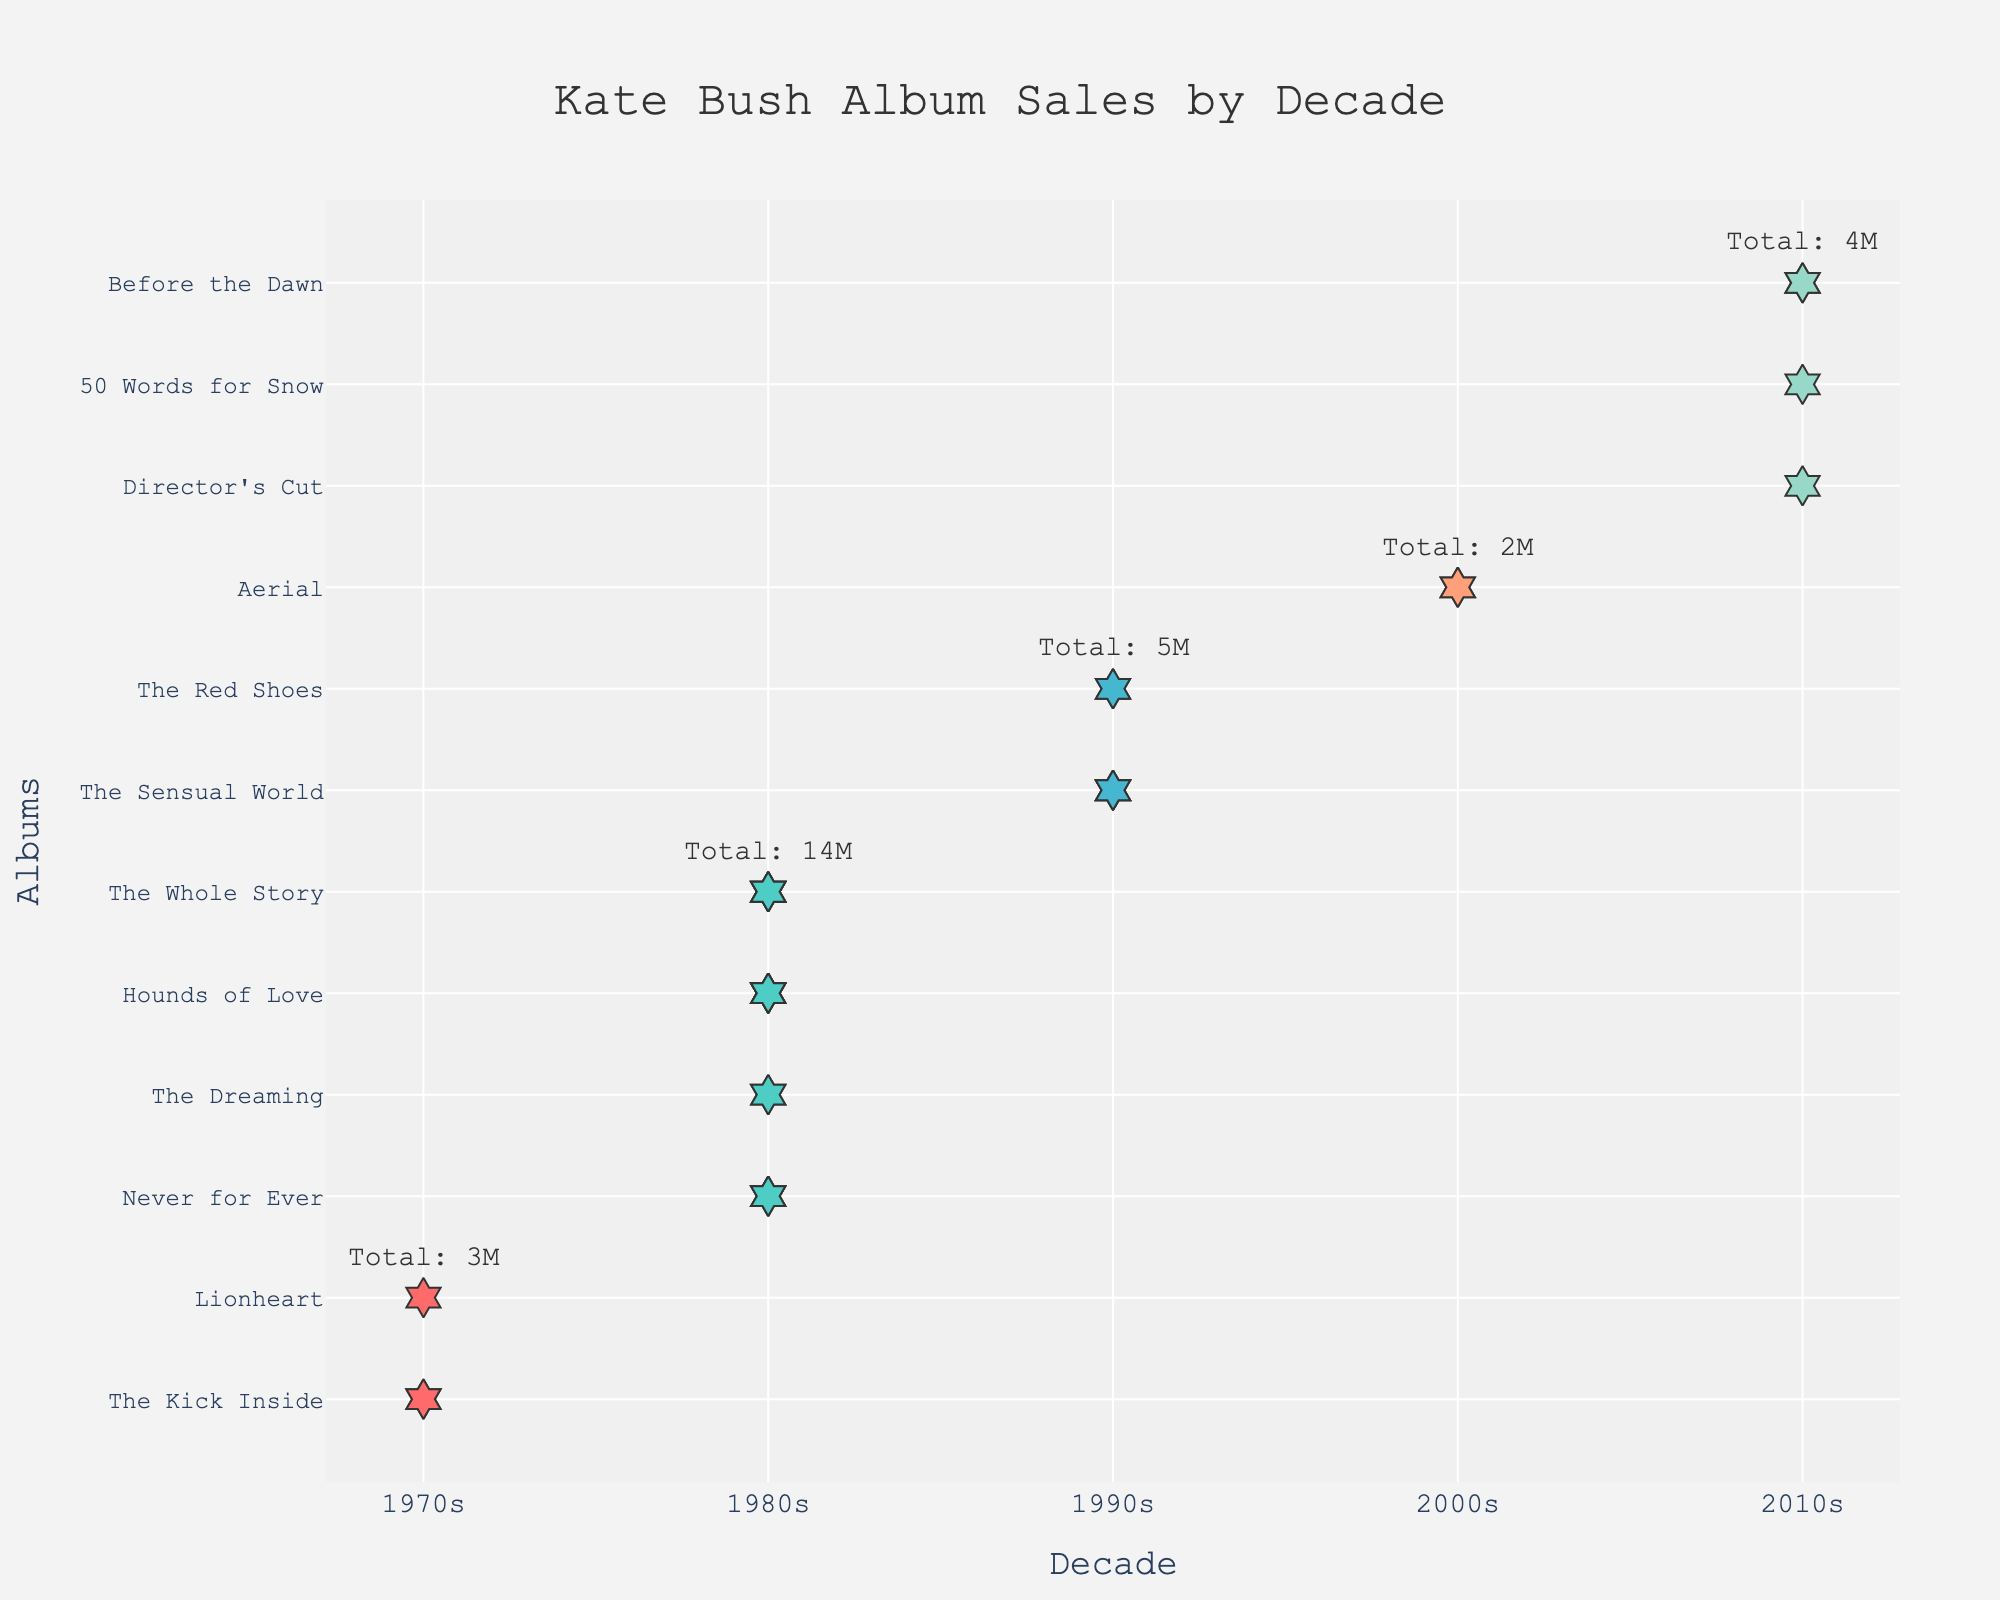What is the title of the plot? The title of the plot is displayed at the top center in a larger font size. It reads "Kate Bush Album Sales by Decade."
Answer: Kate Bush Album Sales by Decade Which decade has the highest total album sales? To find the decade with the highest total album sales, check the annotations by each decade. The 1980s have an annotation indicating a total of 14 million album sales, the highest among all decades.
Answer: 1980s How many albums did Kate Bush release in the 1970s? Check the labels along the y-axis under the 1970s column. The plot indicates that Kate Bush released two albums in the 1970s.
Answer: 2 Which album sold the most units in the 1980s? Look at the individual markers for each album under the 1980s column. "Hounds of Love" appears multiple times (5-markers), indicating it sold the most units in the 1980s.
Answer: Hounds of Love What is the total number of albums represented in the 2000s and 2010s combined? Count the individual album titles for both the 2000s (1 album) and the 2010s (3 albums) and add them together.
Answer: 4 Did Kate Bush release more albums in the 1980s or the 1990s? Compare the count of unique album titles under both the 1980s (4 albums) and the 1990s (2 albums). The 1980s have more albums released.
Answer: 1980s What is the least number of sales units for any album in the 2010s? Refer to the individual sales markers for the albums in the 2010s. The album with the least markers is "Director's Cut" and "50 Words for Snow," each having 1 marker indicating 1 million units sold.
Answer: 1 million Which album has the maximum sales in the 1970s? The album with the maximum markers under the 1970s column is "The Kick Inside," indicated by 2 markers representing 2 million sales.
Answer: The Kick Inside What is the combined sales for all albums released in the 1990s? Sum the sales units for each album in the 1990s; "The Sensual World" (3) + "The Red Shoes" (2) = 5 million units.
Answer: 5 million Which decade has a more significant number of albums released: 1970s or 2010s? Compare the number of unique albums in each decade. The 1970s have 2 albums, and the 2010s have 3 albums.
Answer: 2010s 